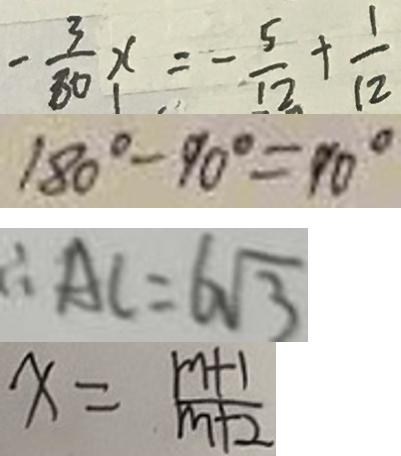Convert formula to latex. <formula><loc_0><loc_0><loc_500><loc_500>- \frac { 3 } { 8 0 } x = - \frac { 5 } { 1 2 } + \frac { 1 } { 1 2 } 
 1 8 0 ^ { \circ } - 9 0 ^ { \circ } = 9 0 ^ { \circ } 
 \therefore A C = 6 \sqrt { 3 } 
 x = \frac { m + 1 } { m + 2 }</formula> 